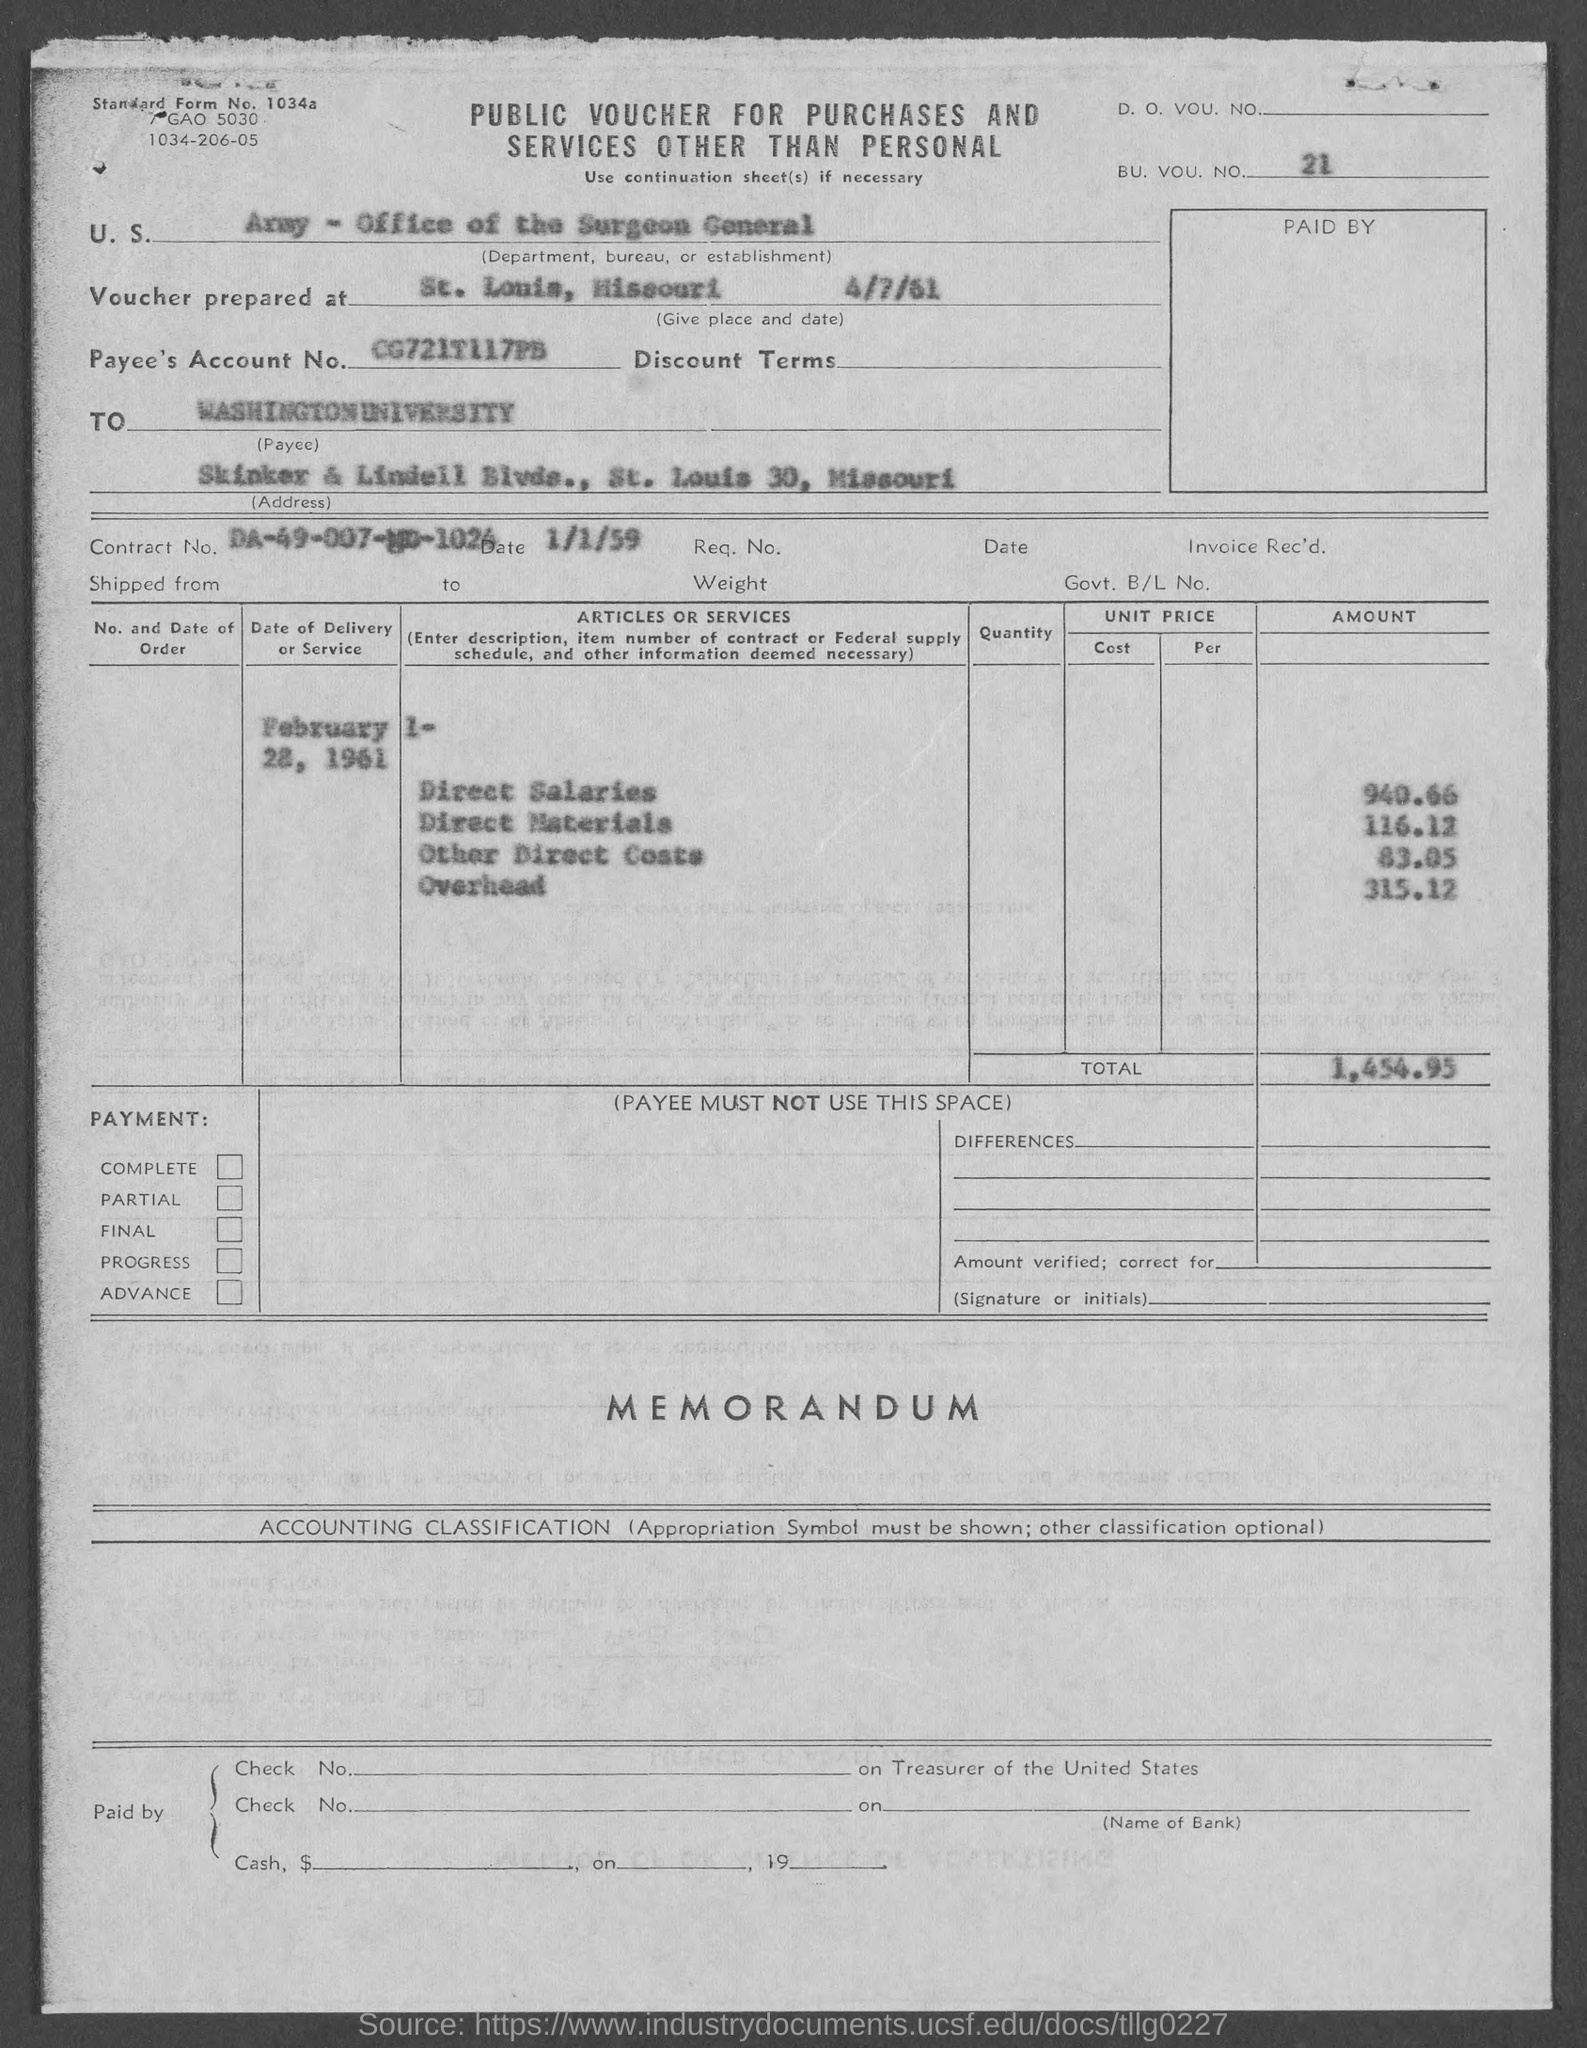What is the bu. vou. no.?
Your response must be concise. 21. What is the payee's account no.?
Provide a succinct answer. CG721T117PB. What is the contract no.?
Your response must be concise. DA-49-007-MD-1024. What is the total amount ?
Ensure brevity in your answer.  1,454.95. 